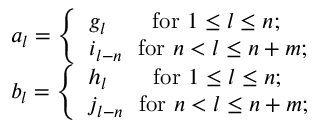Convert formula to latex. <formula><loc_0><loc_0><loc_500><loc_500>\begin{array} { r l } & { a _ { l } = \left \{ \begin{array} { l l } { g _ { l } \quad f o r 1 \leq l \leq n ; } \\ { i _ { l - n } f o r n < l \leq n + m ; } \end{array} } \\ & { b _ { l } = \left \{ \begin{array} { l l } { h _ { l } \quad f o r 1 \leq l \leq n ; } \\ { j _ { l - n } f o r n < l \leq n + m ; } \end{array} } \end{array}</formula> 